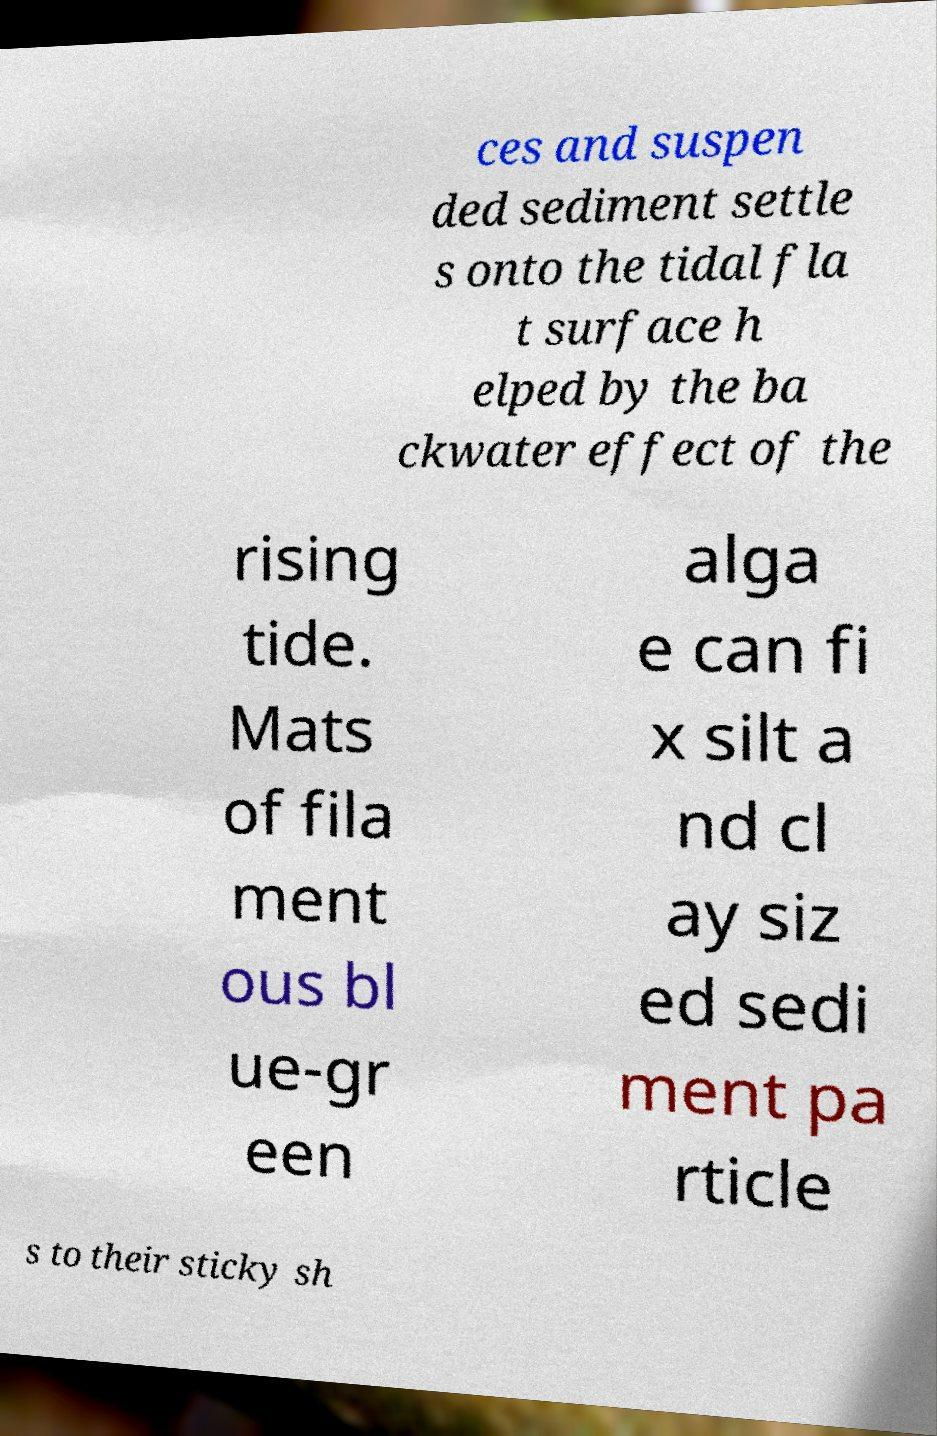Can you accurately transcribe the text from the provided image for me? ces and suspen ded sediment settle s onto the tidal fla t surface h elped by the ba ckwater effect of the rising tide. Mats of fila ment ous bl ue-gr een alga e can fi x silt a nd cl ay siz ed sedi ment pa rticle s to their sticky sh 